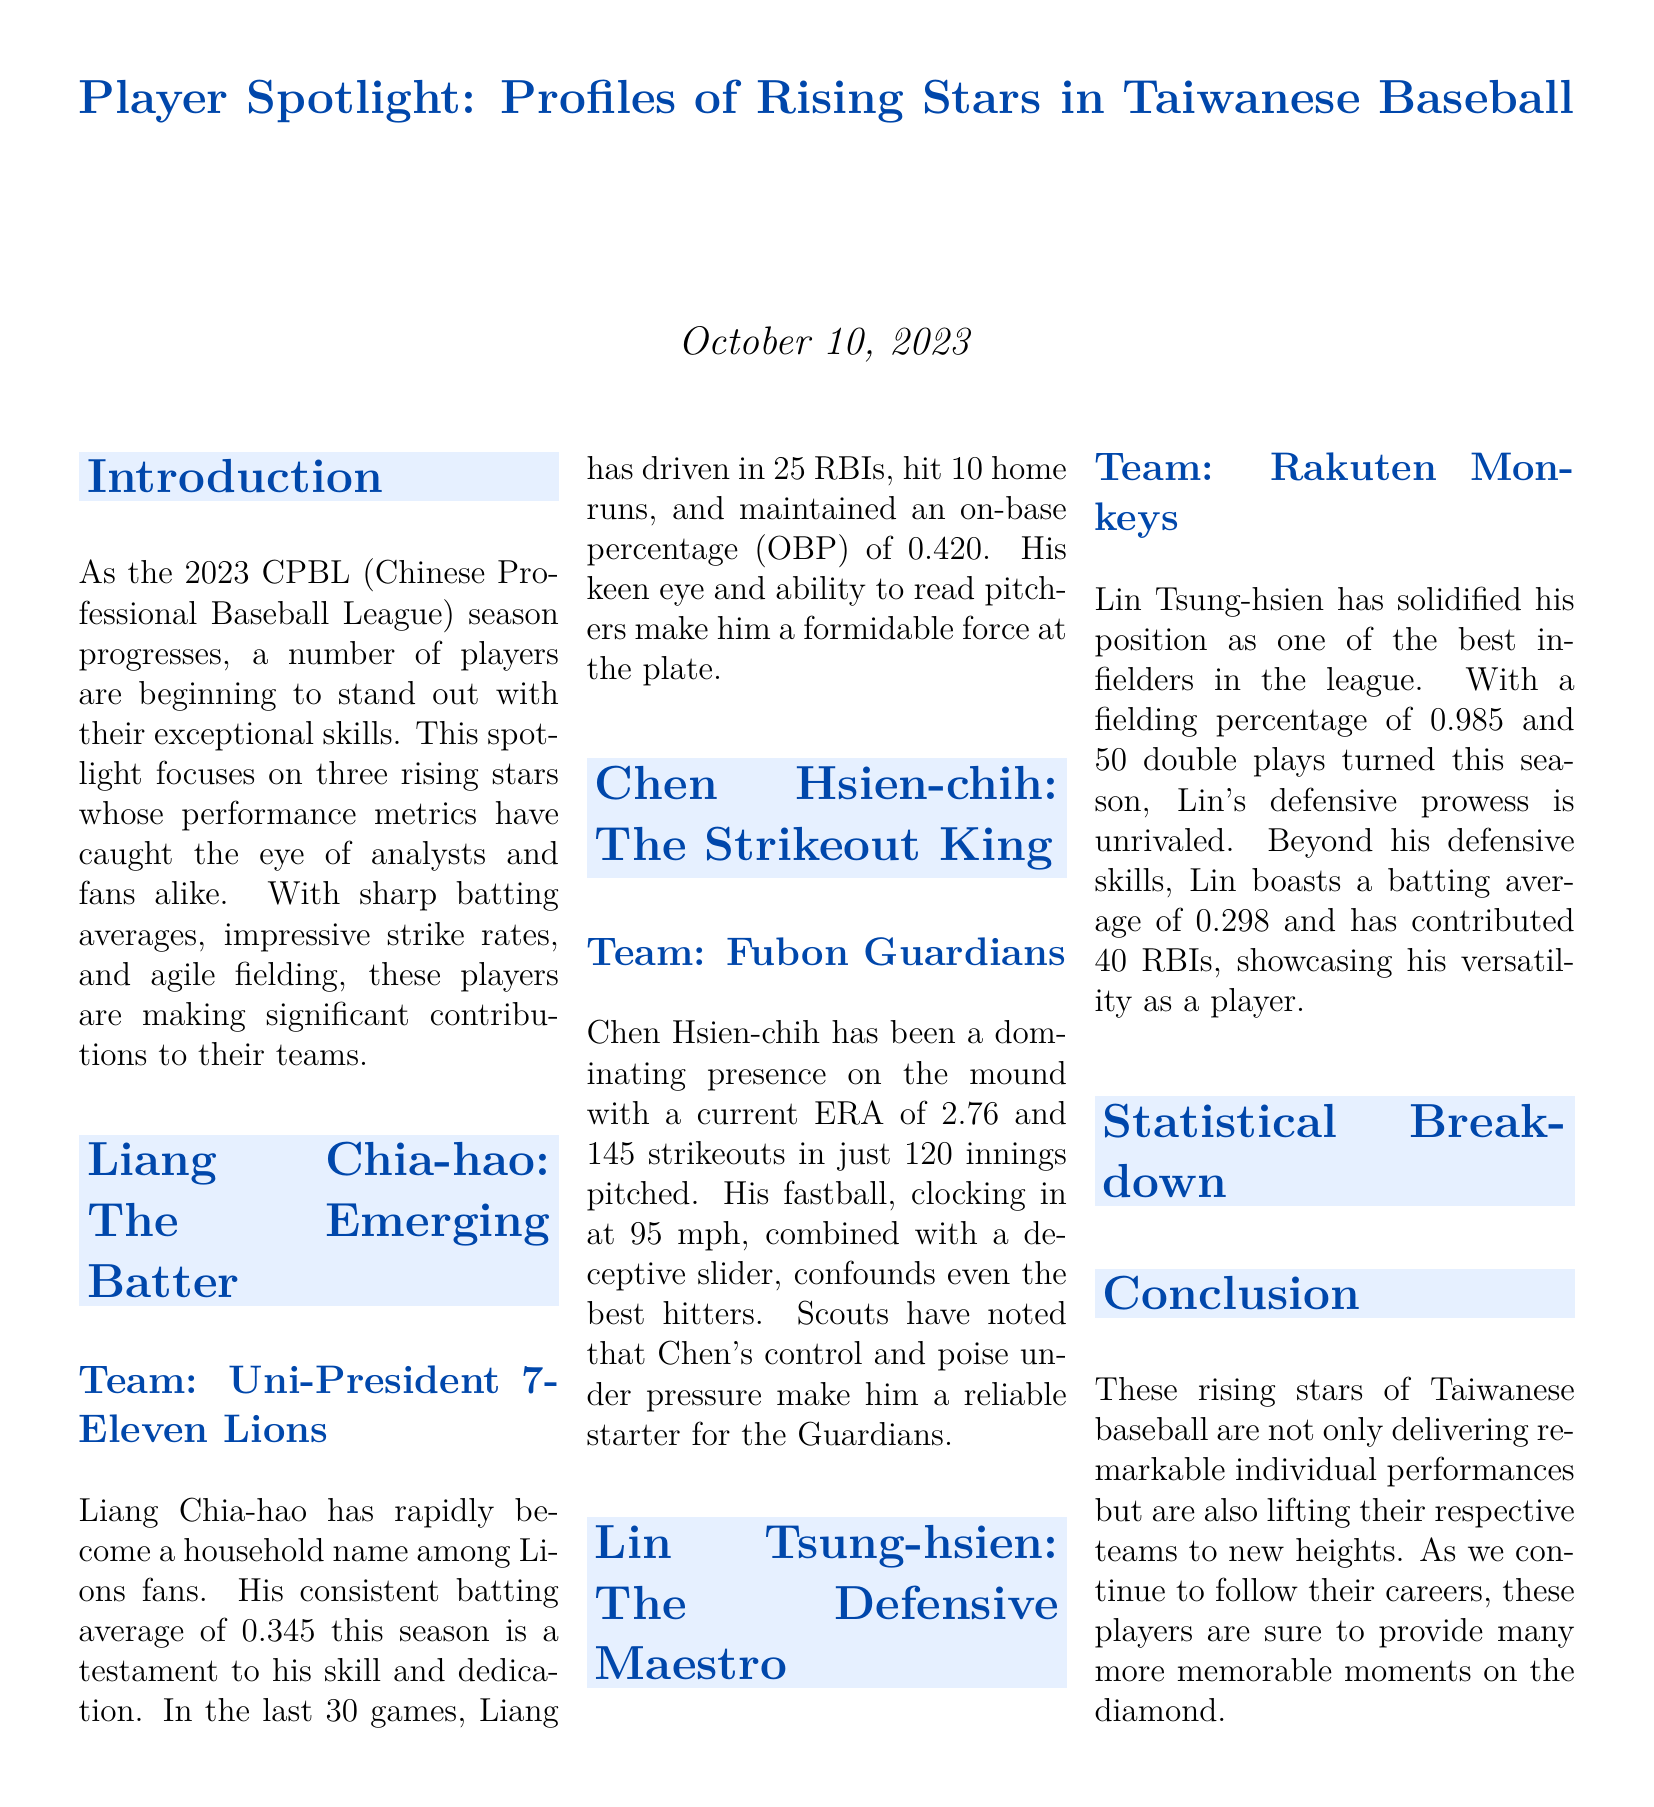What is Liang Chia-hao's batting average? The document states that Liang Chia-hao has a consistent batting average of 0.345 this season.
Answer: 0.345 How many home runs has Chen Hsien-chih allowed this season? The document does not provide information about home runs allowed, as it only mentions his ERA and strikeouts.
Answer: - What is Lin Tsung-hsien's fielding percentage? The document notes that Lin Tsung-hsien has a fielding percentage of 0.985, highlighting his defensive skills.
Answer: 0.985 How many RBIs has Liang Chia-hao driven in during the last 30 games? The document mentions that Liang Chia-hao has driven in 25 RBIs in the last 30 games.
Answer: 25 What team does Lin Tsung-hsien play for? The document specifies that Lin Tsung-hsien plays for the Rakuten Monkeys.
Answer: Rakuten Monkeys What is the ERA of Chen Hsien-chih? The document states that Chen Hsien-chih has a current ERA of 2.76.
Answer: 2.76 How many double plays has Lin Tsung-hsien turned this season? According to the document, Lin Tsung-hsien has turned 50 double plays this season.
Answer: 50 Which player's on-base percentage is the highest in the document? The document highlights Liang Chia-hao's on-base percentage of 0.420 as the highest among the players mentioned.
Answer: 0.420 What is the title of the document? The title of the document is "Player Spotlight: Profiles of Rising Stars in Taiwanese Baseball."
Answer: Player Spotlight: Profiles of Rising Stars in Taiwanese Baseball 